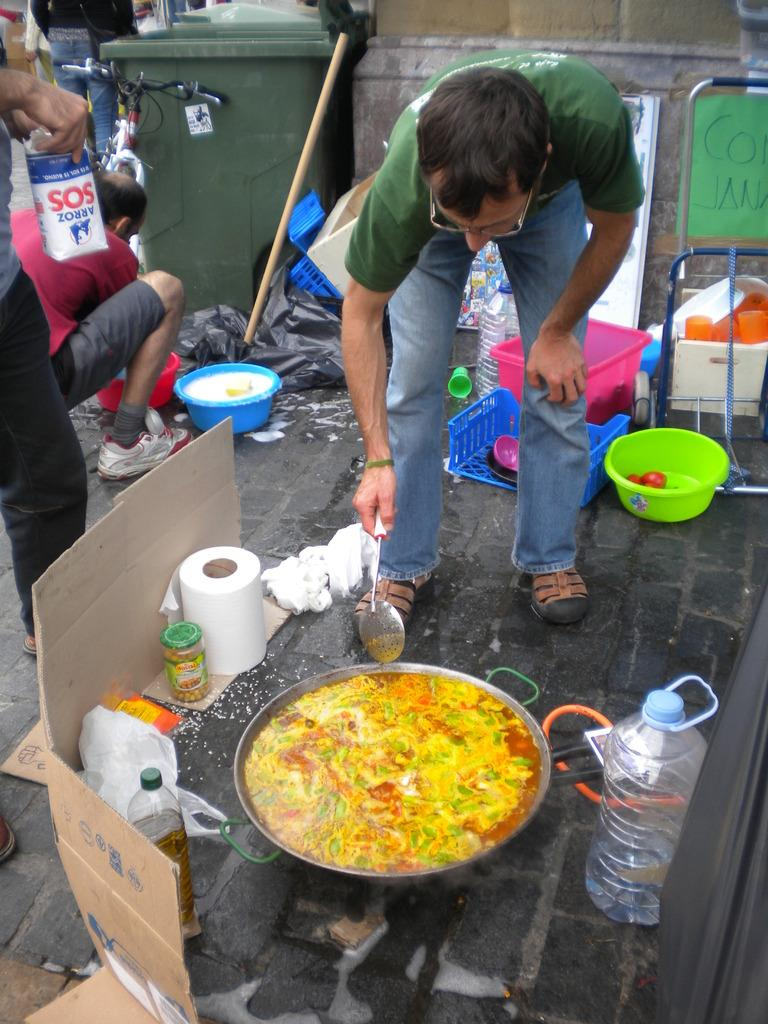What is the man in the image doing? The man is cooking food in a vessel. What items are near the vessel the man is using? There are groceries around the vessel. What can be seen behind the man? There are tubs, a trash bin, and a cycle behind the man. Are there any other people in the image? Yes, there are other people visible in the image. What type of creature is delivering the news in the image? There is no creature delivering news in the image, nor is there any news being delivered. What type of yam is being used in the cooking process in the image? There is no yam mentioned or visible in the image; the man is cooking food in a vessel, but the specific ingredients are not discernible. 